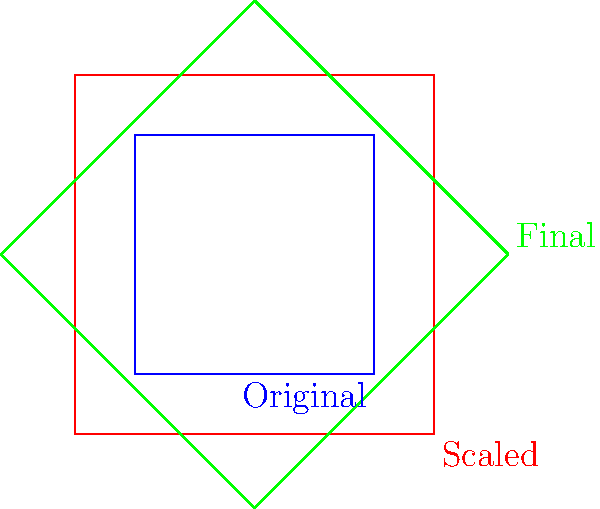You're working on a client's tattoo design, which is initially a square shape. The client wants to enlarge the design by a factor of 1.5 and then rotate it 45 degrees clockwise. If the original design has an area of 16 cm², what is the area of the final transformed design? Let's approach this step-by-step:

1. Original area: The initial square has an area of 16 cm².

2. Scaling: The design is enlarged by a factor of 1.5.
   - The area scaling factor is the square of the linear scaling factor: $1.5^2 = 2.25$
   - New area after scaling: $16 \text{ cm}^2 \times 2.25 = 36 \text{ cm}^2$

3. Rotation: The design is rotated 45 degrees clockwise.
   - Rotation doesn't change the area of a shape, so the area remains 36 cm².

Therefore, the area of the final transformed design is 36 cm².
Answer: 36 cm² 